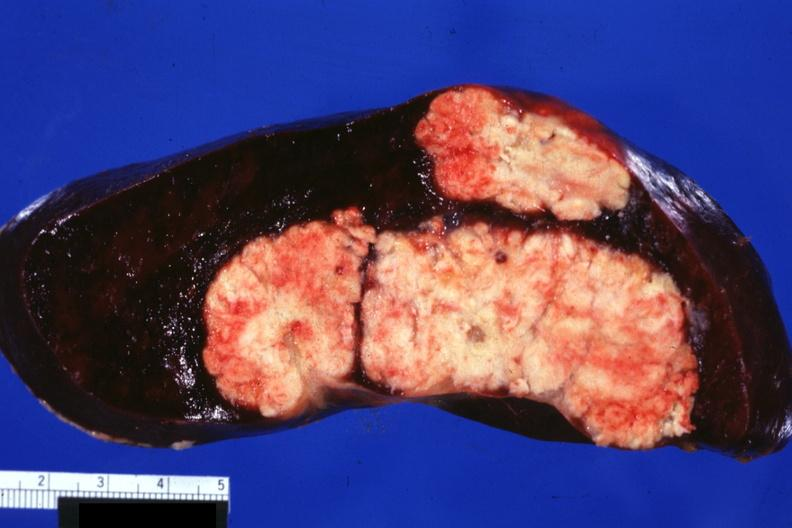s spleen present?
Answer the question using a single word or phrase. Yes 